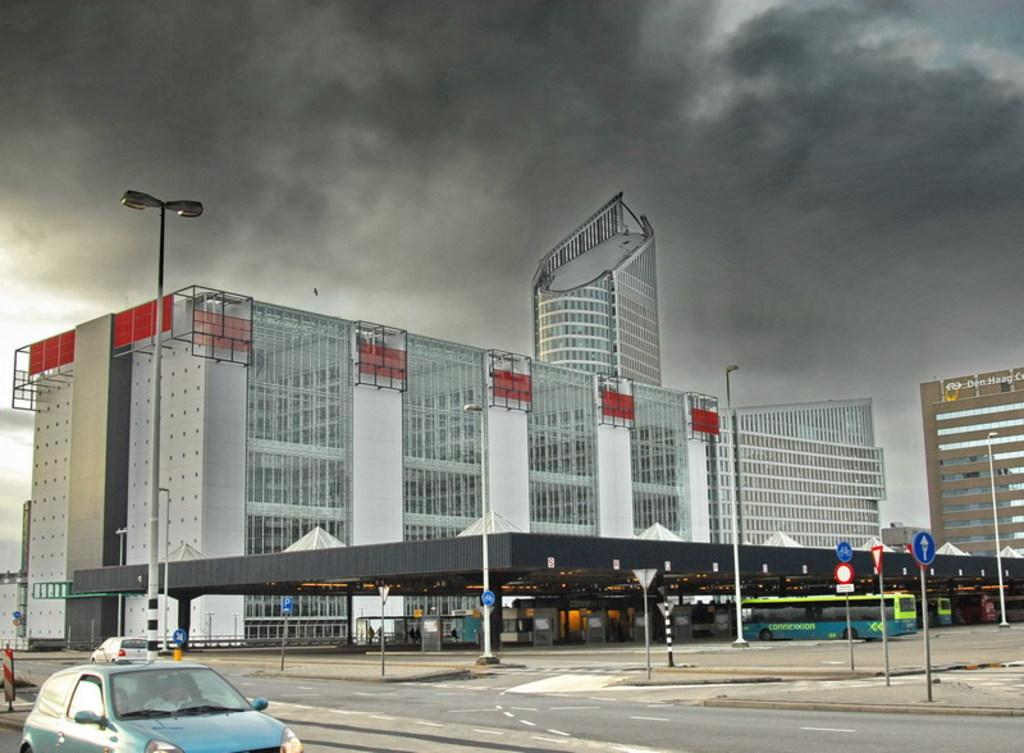What is the main subject of the image? The main subject of the image is an empty road. What can be seen on the road? There are cars visible on the road. What structures are present along the road? There are poles along the road. What type of structure is located beside the road? There is a building beside the road. How many snakes can be seen slithering on the road in the image? There are no snakes visible in the image; it features an empty road with cars and other structures. What is the monetary value of the building beside the road in the image? The provided facts do not include any information about the monetary value of the building, so it cannot be determined from the image. 